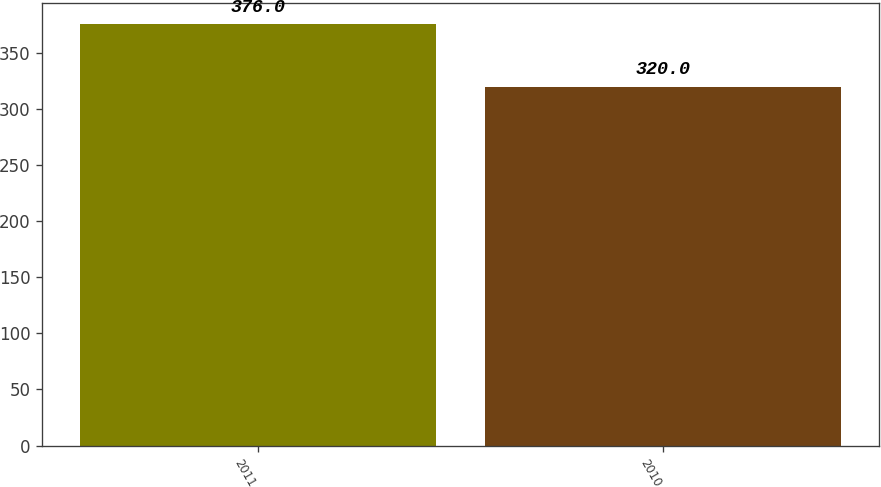Convert chart. <chart><loc_0><loc_0><loc_500><loc_500><bar_chart><fcel>2011<fcel>2010<nl><fcel>376<fcel>320<nl></chart> 